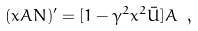Convert formula to latex. <formula><loc_0><loc_0><loc_500><loc_500>( x A N ) ^ { \prime } = [ 1 - \gamma ^ { 2 } x ^ { 2 } \bar { U } ] A \ ,</formula> 